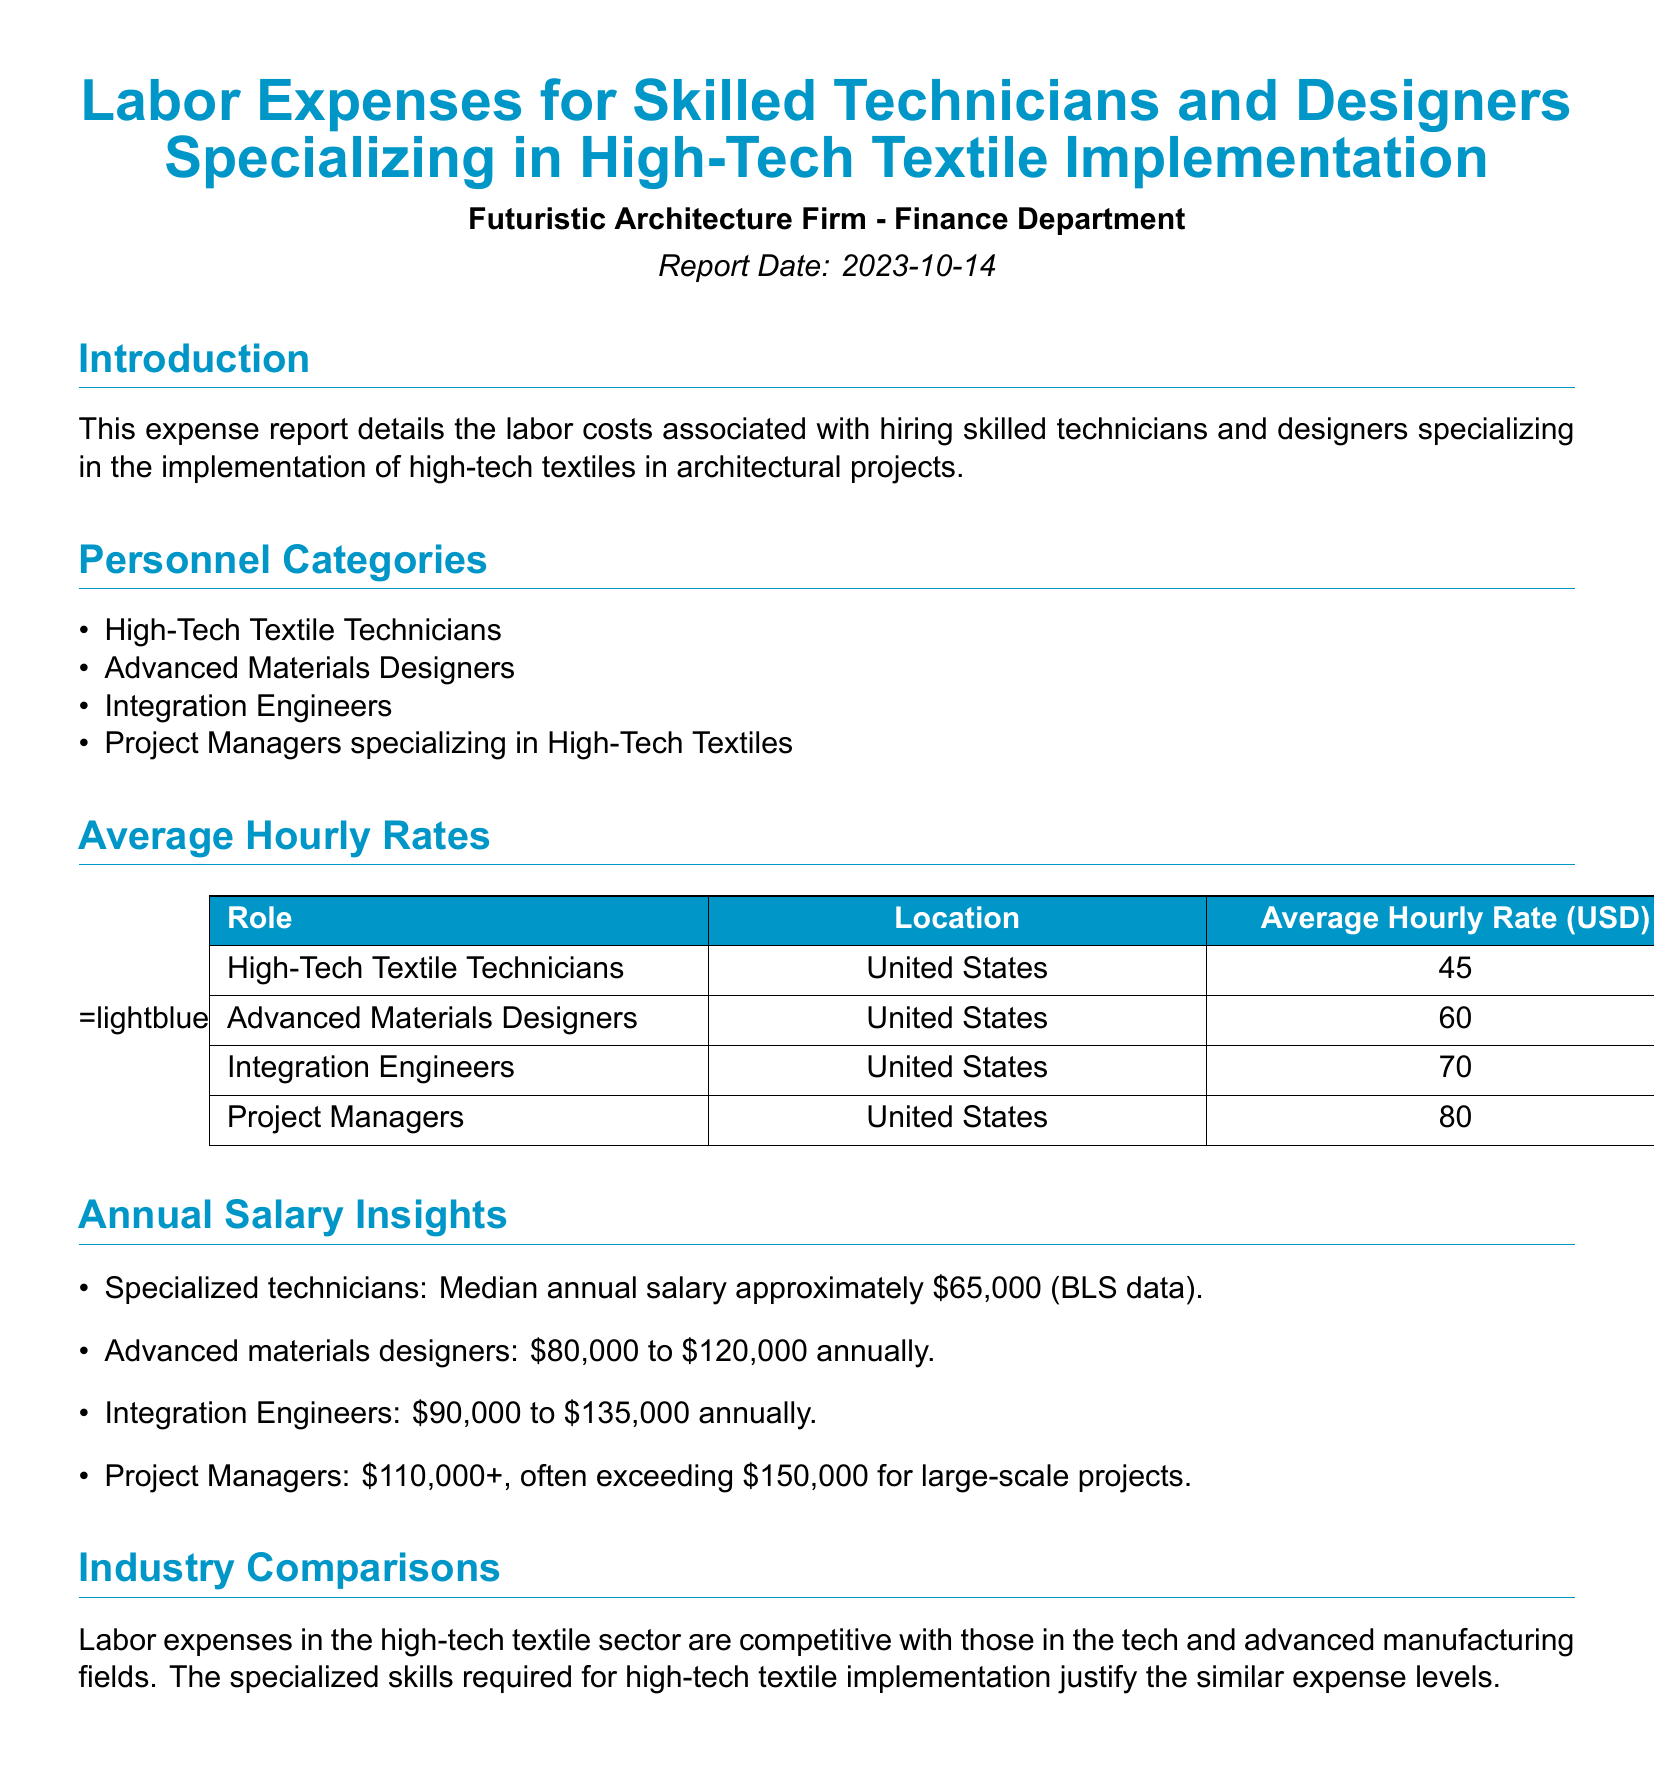What is the report date? The report date is stated in the document, which is 2023-10-14.
Answer: 2023-10-14 What is the average hourly rate for Project Managers? The average hourly rate for Project Managers is listed in the table as 80 USD.
Answer: 80 What is the median annual salary for specialized technicians? The document states that the median annual salary for specialized technicians is approximately 65,000 dollars.
Answer: \$65,000 Which role has the highest average hourly rate? By comparing the average hourly rates listed in the document, Integration Engineers have the highest rate at 70 USD.
Answer: Integration Engineers What can be said about labor expenses in the high-tech textile sector? The report indicates that labor expenses in this sector are competitive with those in tech and advanced manufacturing fields.
Answer: Competitive What is the range of annual salaries for Advanced Materials Designers? The document specifies that the salary range for Advanced Materials Designers is from 80,000 to 120,000 dollars annually.
Answer: 80,000 to 120,000 How many personnel categories are listed in the report? The document enumerates four categories of personnel specializing in high-tech textile implementation.
Answer: Four What color represents the headers in the tables? The color used for the table headers in the document is defined as futuristic, RGB values 0,150,199.
Answer: Futuristic 